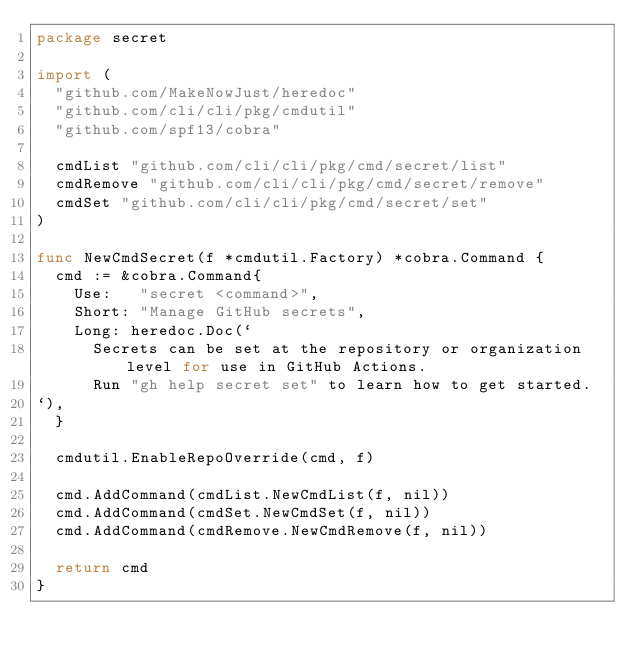<code> <loc_0><loc_0><loc_500><loc_500><_Go_>package secret

import (
	"github.com/MakeNowJust/heredoc"
	"github.com/cli/cli/pkg/cmdutil"
	"github.com/spf13/cobra"

	cmdList "github.com/cli/cli/pkg/cmd/secret/list"
	cmdRemove "github.com/cli/cli/pkg/cmd/secret/remove"
	cmdSet "github.com/cli/cli/pkg/cmd/secret/set"
)

func NewCmdSecret(f *cmdutil.Factory) *cobra.Command {
	cmd := &cobra.Command{
		Use:   "secret <command>",
		Short: "Manage GitHub secrets",
		Long: heredoc.Doc(`
			Secrets can be set at the repository or organization level for use in GitHub Actions.
			Run "gh help secret set" to learn how to get started.
`),
	}

	cmdutil.EnableRepoOverride(cmd, f)

	cmd.AddCommand(cmdList.NewCmdList(f, nil))
	cmd.AddCommand(cmdSet.NewCmdSet(f, nil))
	cmd.AddCommand(cmdRemove.NewCmdRemove(f, nil))

	return cmd
}
</code> 